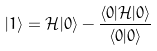Convert formula to latex. <formula><loc_0><loc_0><loc_500><loc_500>| 1 \rangle = { \mathcal { H } } | 0 \rangle - \frac { \langle 0 | { \mathcal { H } } | 0 \rangle } { \langle 0 | 0 \rangle }</formula> 